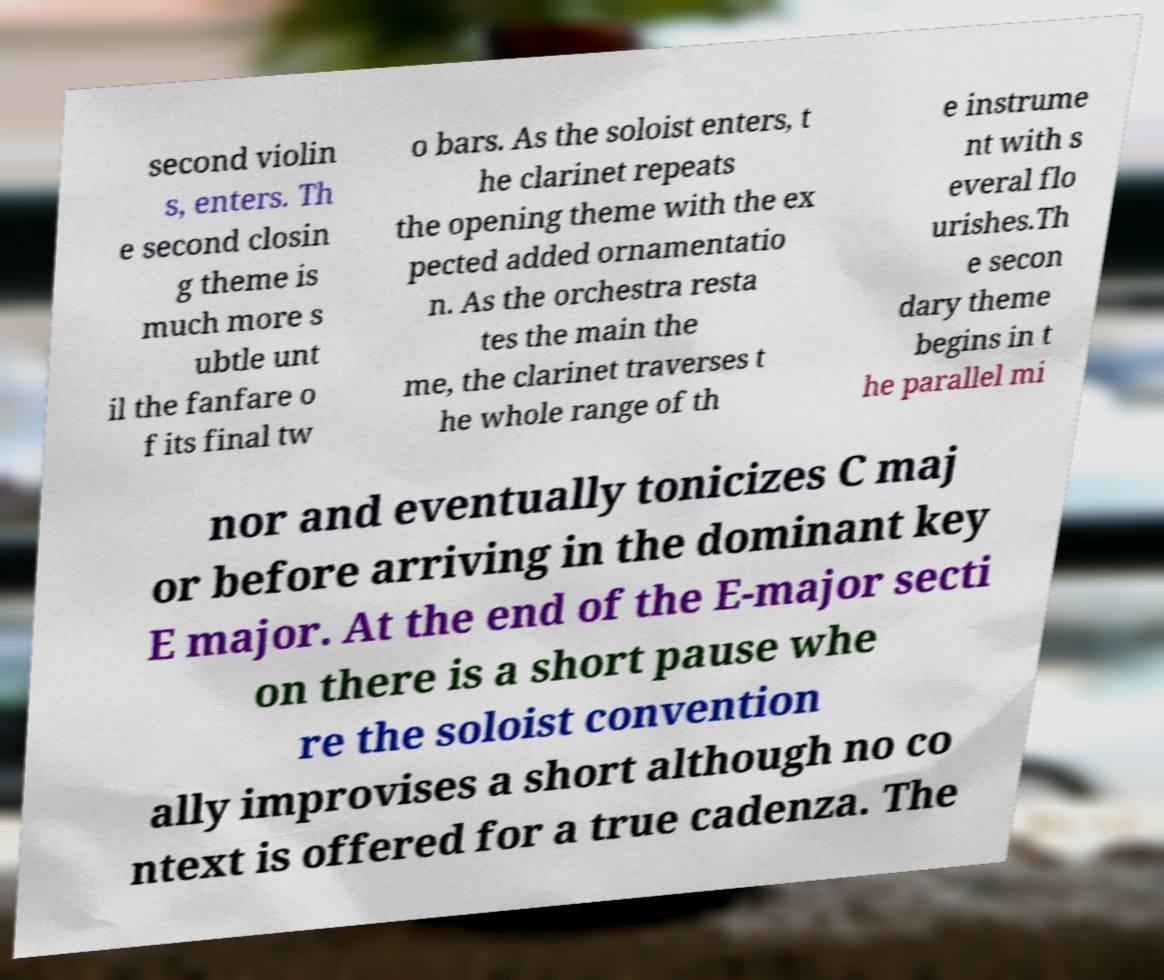I need the written content from this picture converted into text. Can you do that? second violin s, enters. Th e second closin g theme is much more s ubtle unt il the fanfare o f its final tw o bars. As the soloist enters, t he clarinet repeats the opening theme with the ex pected added ornamentatio n. As the orchestra resta tes the main the me, the clarinet traverses t he whole range of th e instrume nt with s everal flo urishes.Th e secon dary theme begins in t he parallel mi nor and eventually tonicizes C maj or before arriving in the dominant key E major. At the end of the E-major secti on there is a short pause whe re the soloist convention ally improvises a short although no co ntext is offered for a true cadenza. The 